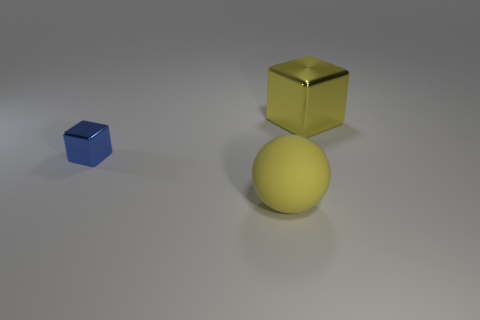Does the yellow shiny thing have the same shape as the small blue shiny thing?
Give a very brief answer. Yes. Are the large thing behind the blue metallic thing and the block that is in front of the large block made of the same material?
Give a very brief answer. Yes. What number of things are small blue cubes or yellow things behind the big matte thing?
Ensure brevity in your answer.  2. How many other things are the same shape as the small metal object?
Keep it short and to the point. 1. There is a object that is the same size as the yellow shiny cube; what is its material?
Give a very brief answer. Rubber. There is a shiny cube that is on the left side of the large object that is left of the metal cube that is on the right side of the rubber ball; what is its size?
Your answer should be very brief. Small. There is a big thing behind the big matte thing; is its color the same as the large object that is in front of the large yellow shiny object?
Your response must be concise. Yes. What number of green objects are small metal objects or big metal things?
Provide a succinct answer. 0. What number of yellow metal cubes are the same size as the yellow rubber object?
Keep it short and to the point. 1. Does the cube on the left side of the big shiny thing have the same material as the big cube?
Make the answer very short. Yes. 